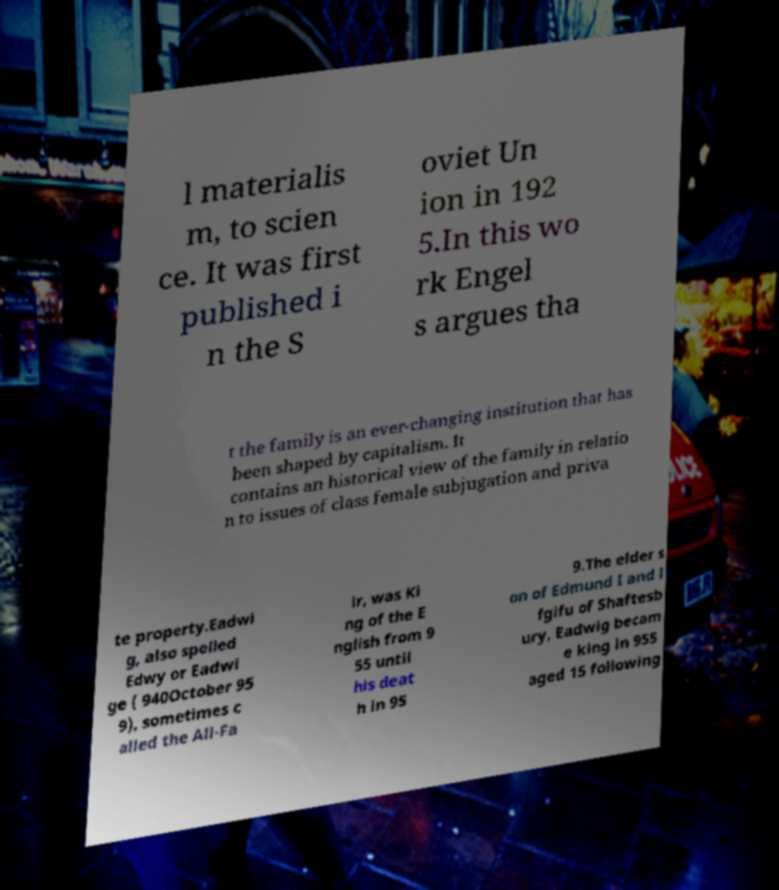I need the written content from this picture converted into text. Can you do that? l materialis m, to scien ce. It was first published i n the S oviet Un ion in 192 5.In this wo rk Engel s argues tha t the family is an ever-changing institution that has been shaped by capitalism. It contains an historical view of the family in relatio n to issues of class female subjugation and priva te property.Eadwi g, also spelled Edwy or Eadwi ge ( 940October 95 9), sometimes c alled the All-Fa ir, was Ki ng of the E nglish from 9 55 until his deat h in 95 9.The elder s on of Edmund I and l fgifu of Shaftesb ury, Eadwig becam e king in 955 aged 15 following 